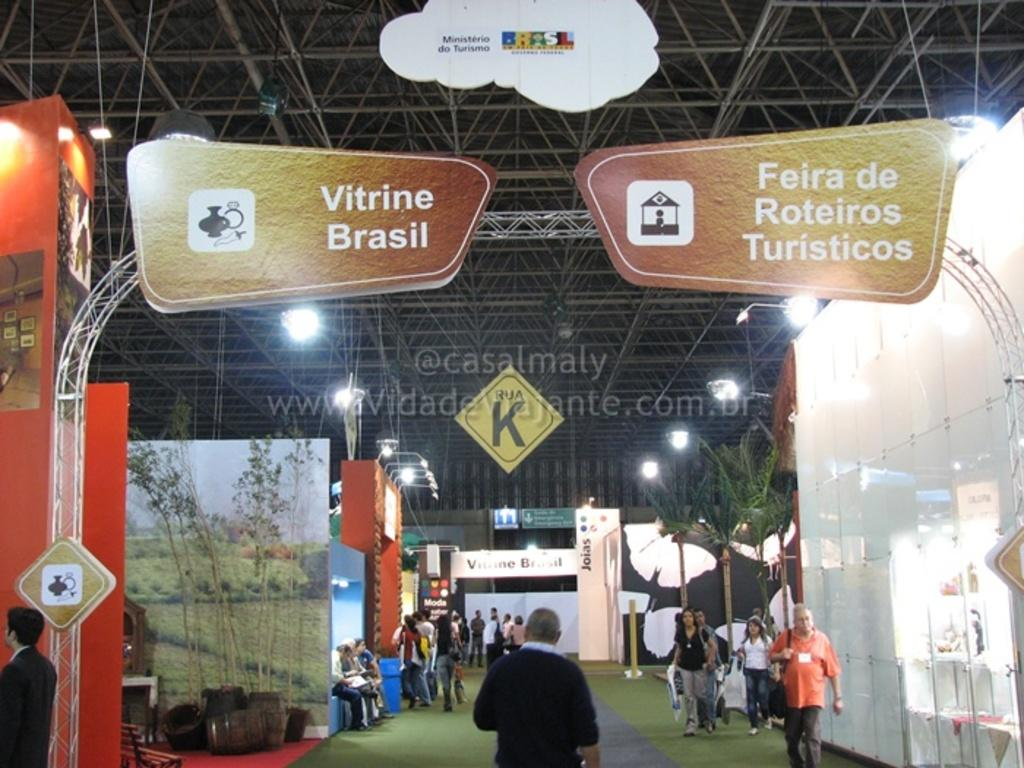What are the people in the image doing? There are persons sitting on the benches and some persons are walking on the floor. What can be seen on the walls or other surfaces in the image? There are advertisements and information boards in the image. What type of lighting is present in the image? Electric lights are visible in the image. What kind of decorative elements are present in the image? Decor trees are present in the image. What type of barrier is visible in the image? Iron grills are visible in the image. What type of acoustics can be heard in the image? There is no information about the acoustics in the image, as it does not mention any sounds or audio. Can you see a guitar in the image? There is no guitar present in the image. 